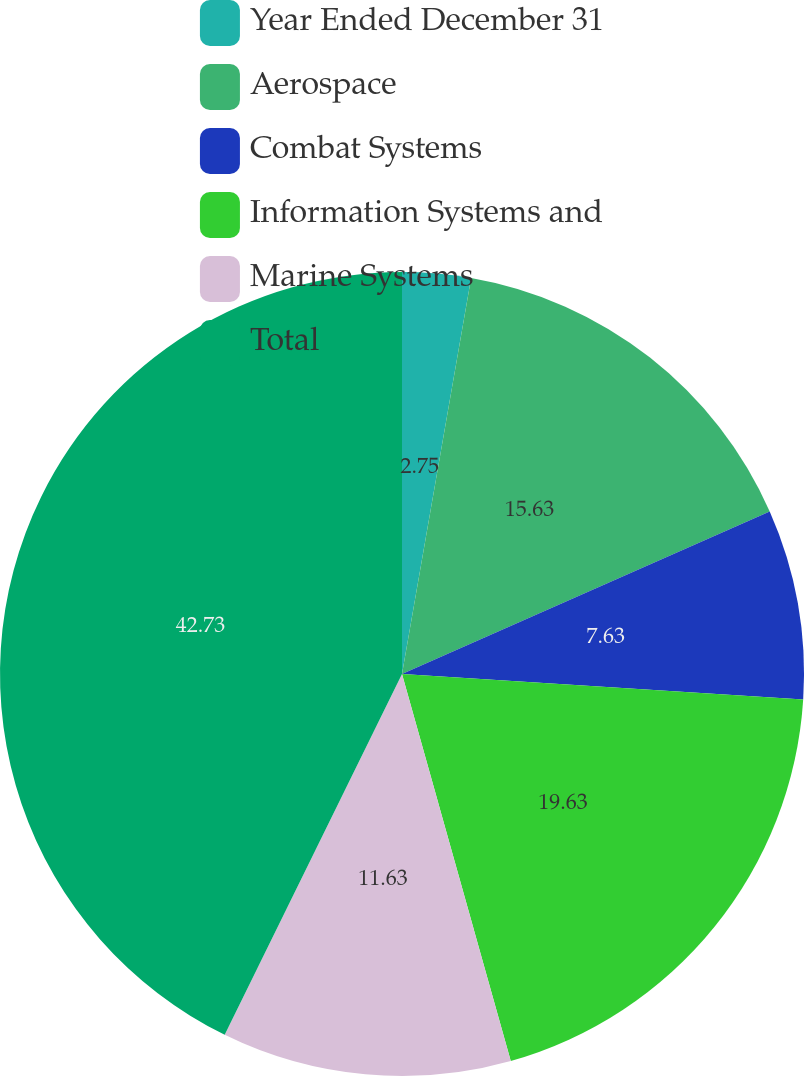Convert chart to OTSL. <chart><loc_0><loc_0><loc_500><loc_500><pie_chart><fcel>Year Ended December 31<fcel>Aerospace<fcel>Combat Systems<fcel>Information Systems and<fcel>Marine Systems<fcel>Total<nl><fcel>2.75%<fcel>15.63%<fcel>7.63%<fcel>19.63%<fcel>11.63%<fcel>42.73%<nl></chart> 